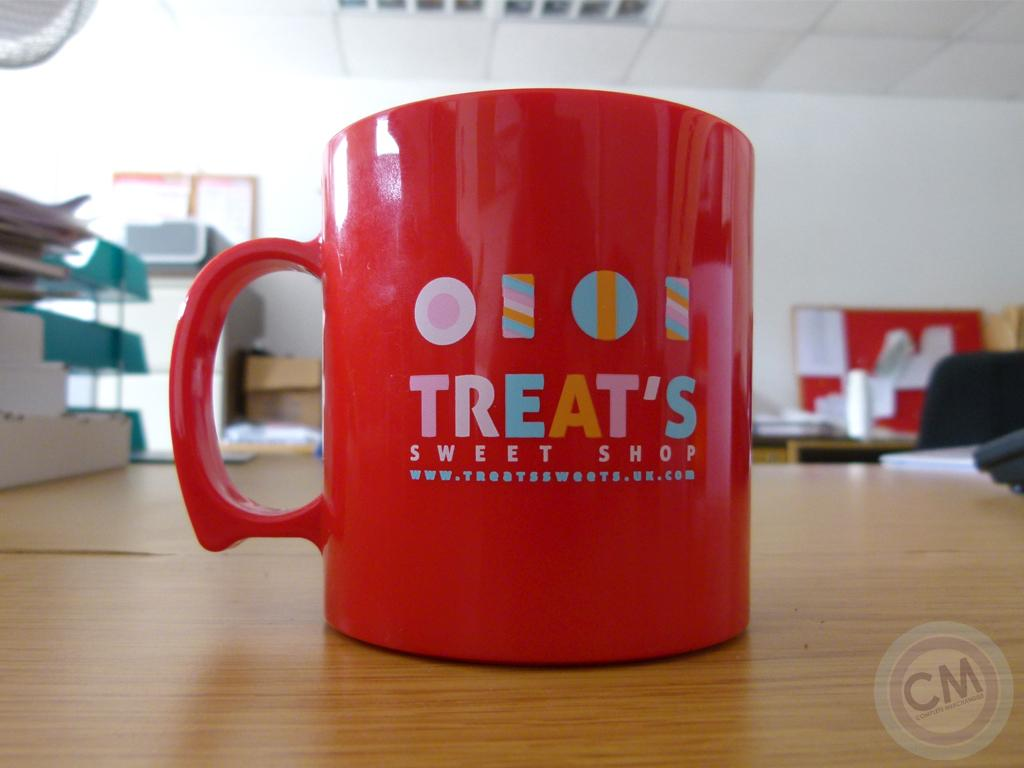<image>
Present a compact description of the photo's key features. A Treat's Sweet Shop red coffee mug sits on top of a table. 